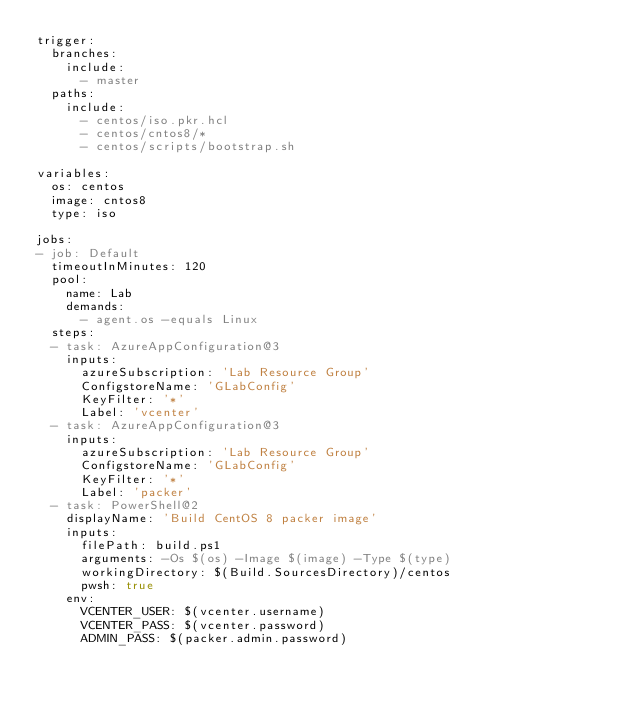<code> <loc_0><loc_0><loc_500><loc_500><_YAML_>trigger:
  branches:
    include:
      - master
  paths:
    include:
      - centos/iso.pkr.hcl
      - centos/cntos8/*
      - centos/scripts/bootstrap.sh

variables:
  os: centos
  image: cntos8
  type: iso

jobs:
- job: Default
  timeoutInMinutes: 120
  pool:
    name: Lab
    demands:
      - agent.os -equals Linux
  steps:
  - task: AzureAppConfiguration@3
    inputs:
      azureSubscription: 'Lab Resource Group'
      ConfigstoreName: 'GLabConfig'
      KeyFilter: '*'
      Label: 'vcenter'
  - task: AzureAppConfiguration@3
    inputs:
      azureSubscription: 'Lab Resource Group'
      ConfigstoreName: 'GLabConfig'
      KeyFilter: '*'
      Label: 'packer'
  - task: PowerShell@2
    displayName: 'Build CentOS 8 packer image'
    inputs:
      filePath: build.ps1
      arguments: -Os $(os) -Image $(image) -Type $(type)
      workingDirectory: $(Build.SourcesDirectory)/centos
      pwsh: true
    env:
      VCENTER_USER: $(vcenter.username)
      VCENTER_PASS: $(vcenter.password)
      ADMIN_PASS: $(packer.admin.password)</code> 